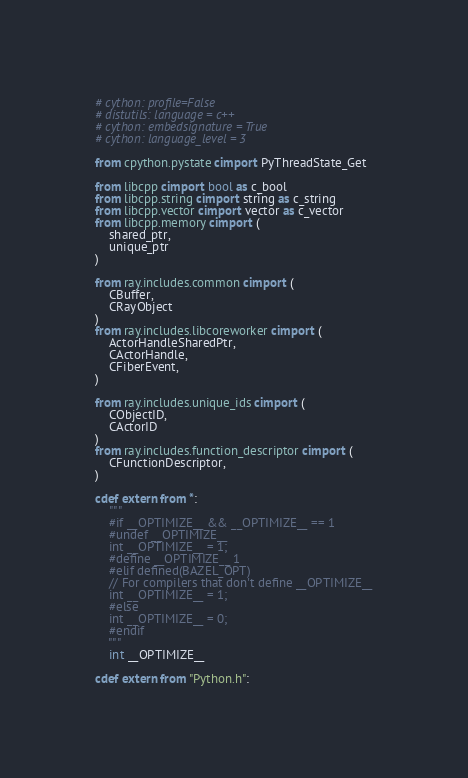Convert code to text. <code><loc_0><loc_0><loc_500><loc_500><_Cython_># cython: profile=False
# distutils: language = c++
# cython: embedsignature = True
# cython: language_level = 3

from cpython.pystate cimport PyThreadState_Get

from libcpp cimport bool as c_bool
from libcpp.string cimport string as c_string
from libcpp.vector cimport vector as c_vector
from libcpp.memory cimport (
    shared_ptr,
    unique_ptr
)

from ray.includes.common cimport (
    CBuffer,
    CRayObject
)
from ray.includes.libcoreworker cimport (
    ActorHandleSharedPtr,
    CActorHandle,
    CFiberEvent,
)

from ray.includes.unique_ids cimport (
    CObjectID,
    CActorID
)
from ray.includes.function_descriptor cimport (
    CFunctionDescriptor,
)

cdef extern from *:
    """
    #if __OPTIMIZE__ && __OPTIMIZE__ == 1
    #undef __OPTIMIZE__
    int __OPTIMIZE__ = 1;
    #define __OPTIMIZE__ 1
    #elif defined(BAZEL_OPT)
    // For compilers that don't define __OPTIMIZE__
    int __OPTIMIZE__ = 1;
    #else
    int __OPTIMIZE__ = 0;
    #endif
    """
    int __OPTIMIZE__

cdef extern from "Python.h":</code> 